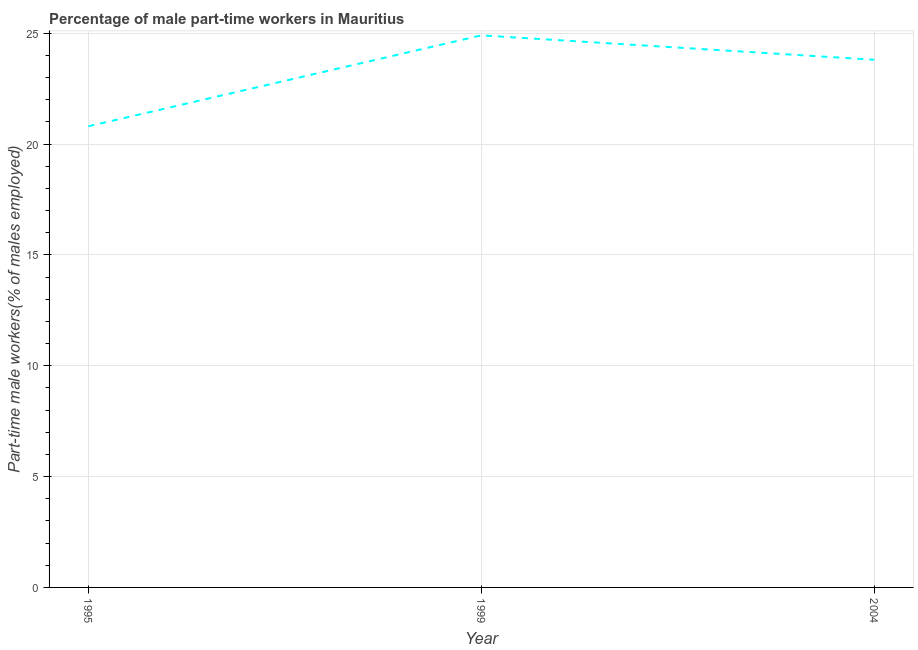What is the percentage of part-time male workers in 1995?
Provide a succinct answer. 20.8. Across all years, what is the maximum percentage of part-time male workers?
Make the answer very short. 24.9. Across all years, what is the minimum percentage of part-time male workers?
Make the answer very short. 20.8. In which year was the percentage of part-time male workers maximum?
Your response must be concise. 1999. In which year was the percentage of part-time male workers minimum?
Offer a very short reply. 1995. What is the sum of the percentage of part-time male workers?
Keep it short and to the point. 69.5. What is the difference between the percentage of part-time male workers in 1995 and 2004?
Provide a succinct answer. -3. What is the average percentage of part-time male workers per year?
Your response must be concise. 23.17. What is the median percentage of part-time male workers?
Give a very brief answer. 23.8. In how many years, is the percentage of part-time male workers greater than 7 %?
Your response must be concise. 3. Do a majority of the years between 1995 and 2004 (inclusive) have percentage of part-time male workers greater than 21 %?
Offer a terse response. Yes. What is the ratio of the percentage of part-time male workers in 1995 to that in 1999?
Your response must be concise. 0.84. Is the difference between the percentage of part-time male workers in 1995 and 2004 greater than the difference between any two years?
Your answer should be compact. No. What is the difference between the highest and the second highest percentage of part-time male workers?
Ensure brevity in your answer.  1.1. What is the difference between the highest and the lowest percentage of part-time male workers?
Make the answer very short. 4.1. In how many years, is the percentage of part-time male workers greater than the average percentage of part-time male workers taken over all years?
Offer a terse response. 2. Does the percentage of part-time male workers monotonically increase over the years?
Make the answer very short. No. What is the difference between two consecutive major ticks on the Y-axis?
Keep it short and to the point. 5. Are the values on the major ticks of Y-axis written in scientific E-notation?
Your answer should be very brief. No. Does the graph contain any zero values?
Offer a terse response. No. What is the title of the graph?
Your response must be concise. Percentage of male part-time workers in Mauritius. What is the label or title of the X-axis?
Your answer should be very brief. Year. What is the label or title of the Y-axis?
Give a very brief answer. Part-time male workers(% of males employed). What is the Part-time male workers(% of males employed) in 1995?
Ensure brevity in your answer.  20.8. What is the Part-time male workers(% of males employed) of 1999?
Give a very brief answer. 24.9. What is the Part-time male workers(% of males employed) of 2004?
Make the answer very short. 23.8. What is the difference between the Part-time male workers(% of males employed) in 1995 and 2004?
Your answer should be very brief. -3. What is the difference between the Part-time male workers(% of males employed) in 1999 and 2004?
Your answer should be very brief. 1.1. What is the ratio of the Part-time male workers(% of males employed) in 1995 to that in 1999?
Your response must be concise. 0.83. What is the ratio of the Part-time male workers(% of males employed) in 1995 to that in 2004?
Offer a terse response. 0.87. What is the ratio of the Part-time male workers(% of males employed) in 1999 to that in 2004?
Your answer should be compact. 1.05. 